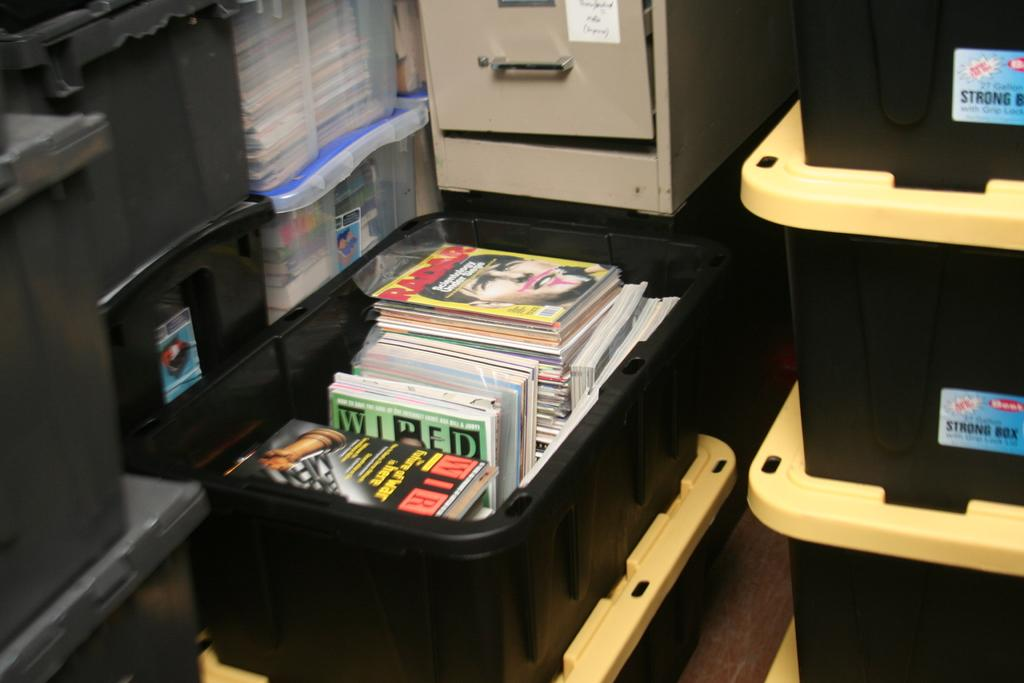<image>
Write a terse but informative summary of the picture. a box of magazines, including a copy of WIRED 